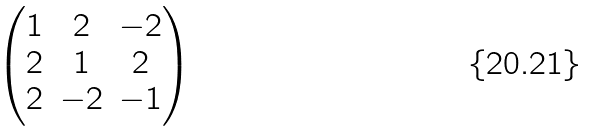Convert formula to latex. <formula><loc_0><loc_0><loc_500><loc_500>\begin{pmatrix} 1 & 2 & - 2 \\ 2 & 1 & 2 \\ 2 & - 2 & - 1 \end{pmatrix}</formula> 